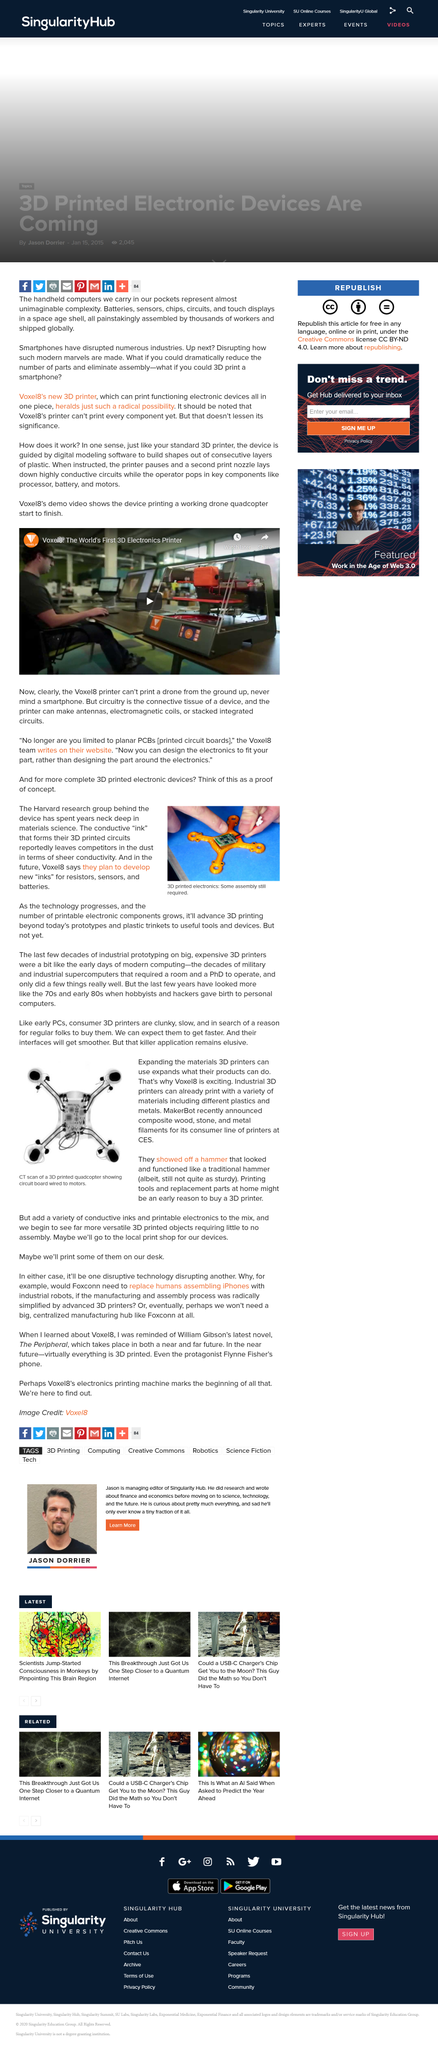Specify some key components in this picture. The connective tissue of a device is known as circuitry, which facilitates the flow of electrical signals and enables the device to function properly. The image is indeed a CT scan. It is currently not possible to print all of the components necessary for the Voxel8's 3D printer using the Voxel8 3D printer. Our conductive ink, derived from 3D printed circuits, outperforms all competitors in terms of its exceptional conductivity. Voxel8 plans to develop new inks for resistors, sensors, and batteries in the future. 